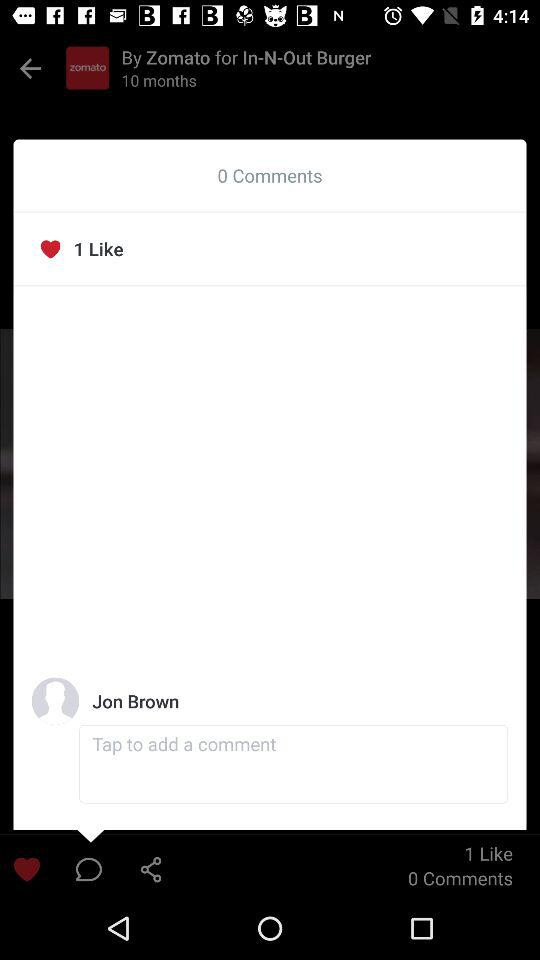How many comments are shown? There are 0 comments shown. 